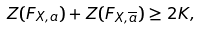Convert formula to latex. <formula><loc_0><loc_0><loc_500><loc_500>Z ( F _ { X , a } ) + Z ( F _ { X , \overline { a } } ) \geq 2 K ,</formula> 